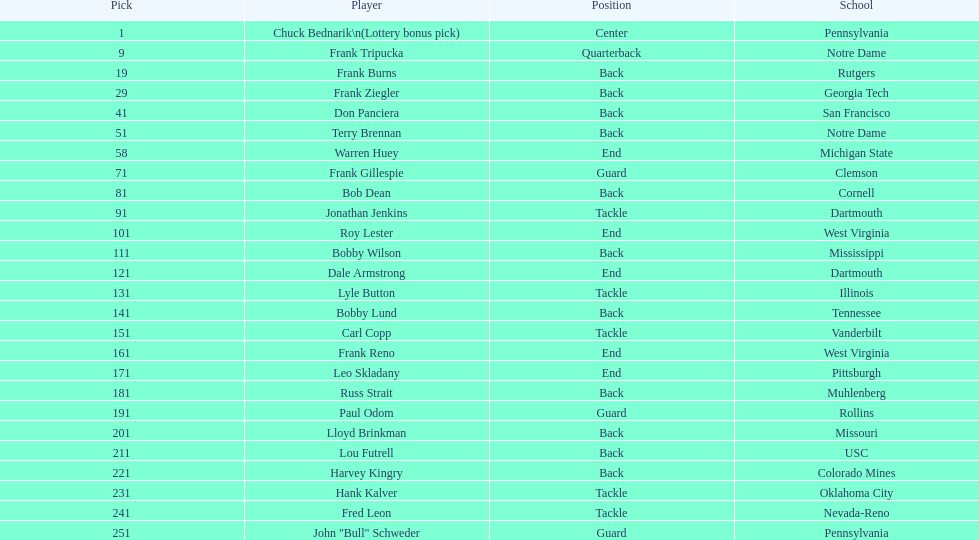Who has same position as frank gillespie? Paul Odom, John "Bull" Schweder. 